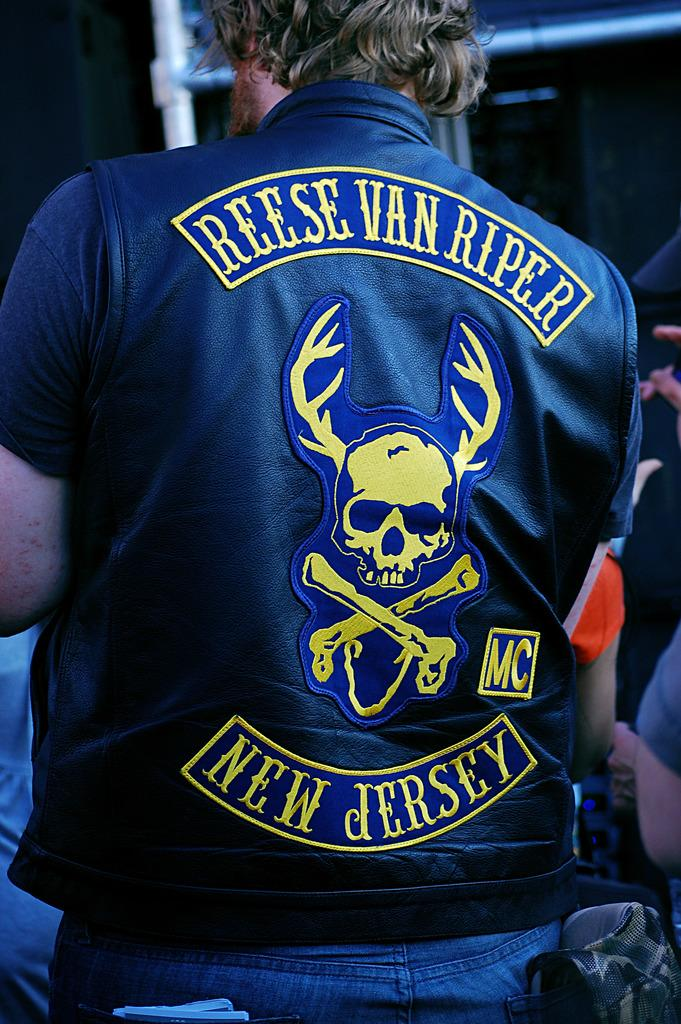What is the main subject of the image? There is a person standing in the image. What is the person wearing? The person is wearing a blue shirt and blue pants. Can you describe the background of the image? There are other persons visible in the background of the image, and there is a pole in the background as well. Can you see the boundary between the ocean and the sky in the image? There is no ocean present in the image, so it is not possible to see the boundary between the ocean and the sky. 